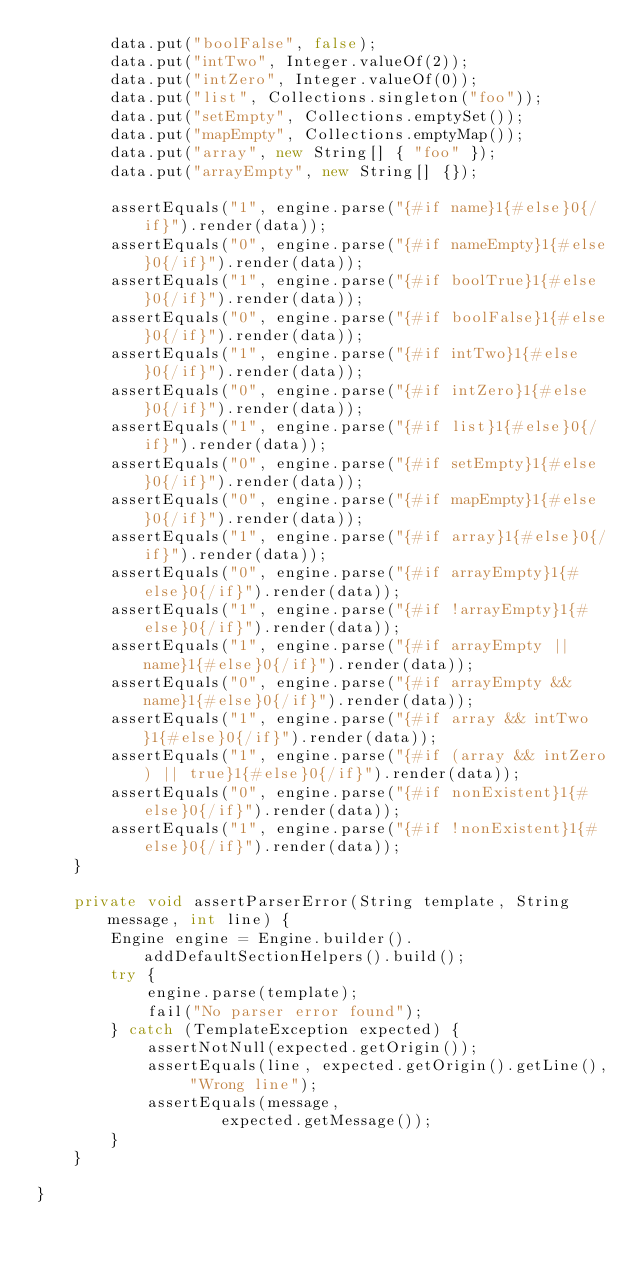<code> <loc_0><loc_0><loc_500><loc_500><_Java_>        data.put("boolFalse", false);
        data.put("intTwo", Integer.valueOf(2));
        data.put("intZero", Integer.valueOf(0));
        data.put("list", Collections.singleton("foo"));
        data.put("setEmpty", Collections.emptySet());
        data.put("mapEmpty", Collections.emptyMap());
        data.put("array", new String[] { "foo" });
        data.put("arrayEmpty", new String[] {});

        assertEquals("1", engine.parse("{#if name}1{#else}0{/if}").render(data));
        assertEquals("0", engine.parse("{#if nameEmpty}1{#else}0{/if}").render(data));
        assertEquals("1", engine.parse("{#if boolTrue}1{#else}0{/if}").render(data));
        assertEquals("0", engine.parse("{#if boolFalse}1{#else}0{/if}").render(data));
        assertEquals("1", engine.parse("{#if intTwo}1{#else}0{/if}").render(data));
        assertEquals("0", engine.parse("{#if intZero}1{#else}0{/if}").render(data));
        assertEquals("1", engine.parse("{#if list}1{#else}0{/if}").render(data));
        assertEquals("0", engine.parse("{#if setEmpty}1{#else}0{/if}").render(data));
        assertEquals("0", engine.parse("{#if mapEmpty}1{#else}0{/if}").render(data));
        assertEquals("1", engine.parse("{#if array}1{#else}0{/if}").render(data));
        assertEquals("0", engine.parse("{#if arrayEmpty}1{#else}0{/if}").render(data));
        assertEquals("1", engine.parse("{#if !arrayEmpty}1{#else}0{/if}").render(data));
        assertEquals("1", engine.parse("{#if arrayEmpty || name}1{#else}0{/if}").render(data));
        assertEquals("0", engine.parse("{#if arrayEmpty && name}1{#else}0{/if}").render(data));
        assertEquals("1", engine.parse("{#if array && intTwo}1{#else}0{/if}").render(data));
        assertEquals("1", engine.parse("{#if (array && intZero) || true}1{#else}0{/if}").render(data));
        assertEquals("0", engine.parse("{#if nonExistent}1{#else}0{/if}").render(data));
        assertEquals("1", engine.parse("{#if !nonExistent}1{#else}0{/if}").render(data));
    }

    private void assertParserError(String template, String message, int line) {
        Engine engine = Engine.builder().addDefaultSectionHelpers().build();
        try {
            engine.parse(template);
            fail("No parser error found");
        } catch (TemplateException expected) {
            assertNotNull(expected.getOrigin());
            assertEquals(line, expected.getOrigin().getLine(), "Wrong line");
            assertEquals(message,
                    expected.getMessage());
        }
    }

}
</code> 